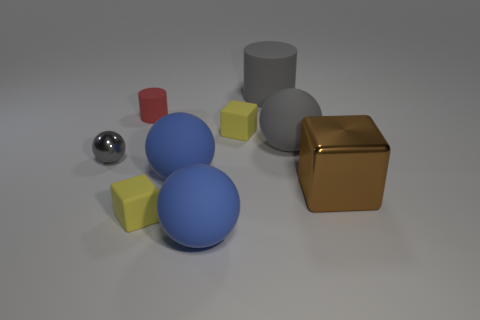Subtract all tiny gray metal balls. How many balls are left? 3 Add 1 big blue matte balls. How many objects exist? 10 Subtract all gray spheres. How many spheres are left? 2 Subtract all cyan spheres. How many yellow cubes are left? 2 Subtract all cylinders. How many objects are left? 7 Subtract all yellow blocks. Subtract all blue spheres. How many blocks are left? 1 Subtract all tiny cylinders. Subtract all small red objects. How many objects are left? 7 Add 6 tiny shiny objects. How many tiny shiny objects are left? 7 Add 6 large green matte blocks. How many large green matte blocks exist? 6 Subtract 1 red cylinders. How many objects are left? 8 